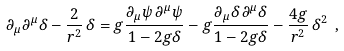Convert formula to latex. <formula><loc_0><loc_0><loc_500><loc_500>\partial _ { \mu } \partial ^ { \mu } \delta - \frac { 2 } { r ^ { 2 } } \, \delta = g \frac { \partial _ { \mu } \psi \, \partial ^ { \mu } \psi } { 1 - 2 g \delta } - g \frac { \partial _ { \mu } \delta \, \partial ^ { \mu } \delta } { 1 - 2 g \delta } - \frac { 4 g } { r ^ { 2 } } \, \delta ^ { 2 } \ ,</formula> 